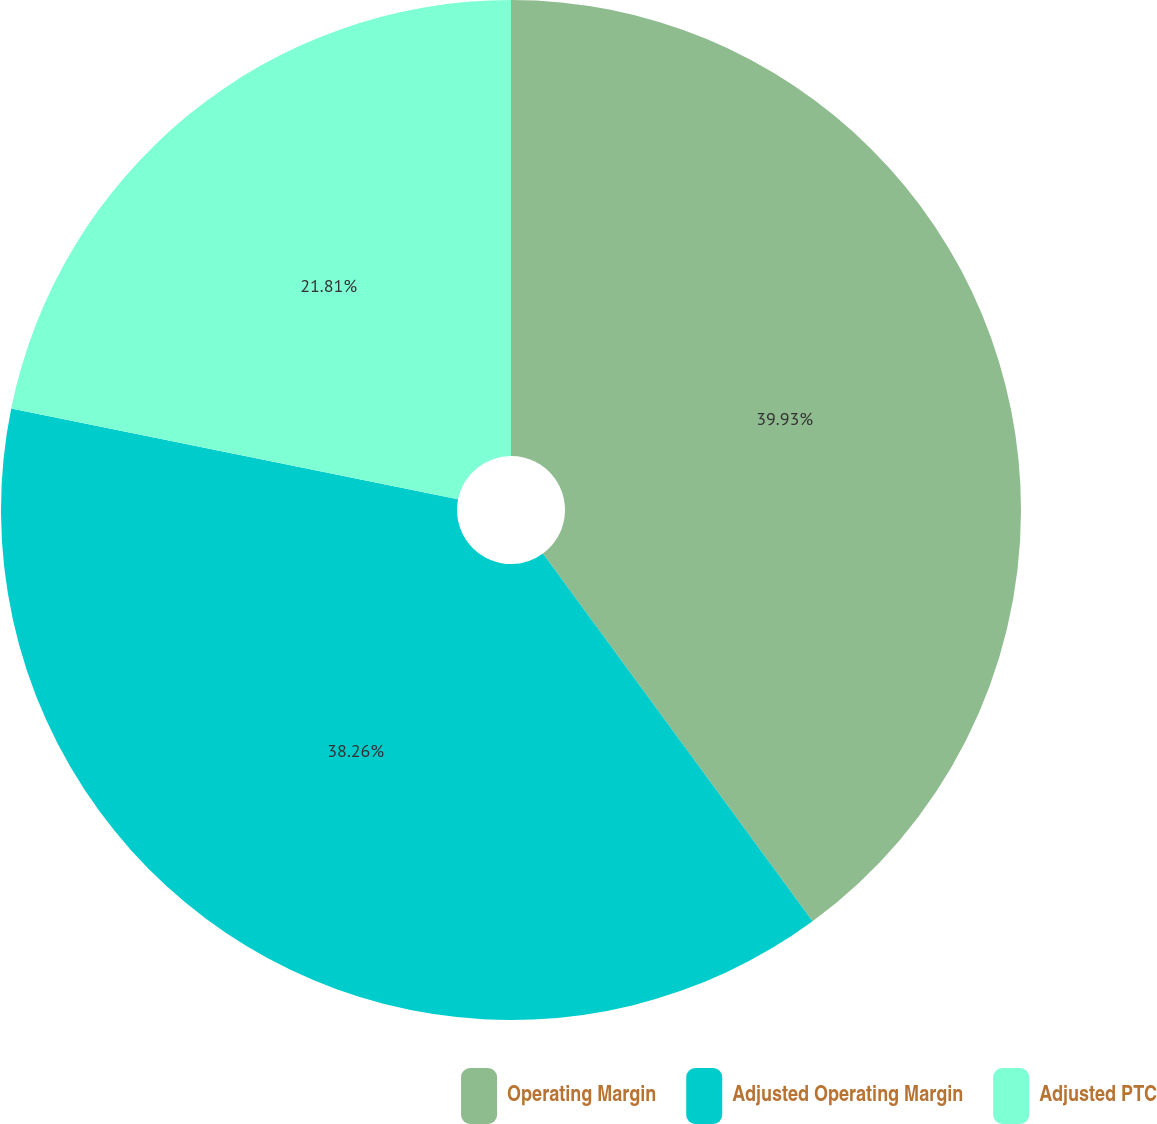Convert chart to OTSL. <chart><loc_0><loc_0><loc_500><loc_500><pie_chart><fcel>Operating Margin<fcel>Adjusted Operating Margin<fcel>Adjusted PTC<nl><fcel>39.93%<fcel>38.26%<fcel>21.81%<nl></chart> 